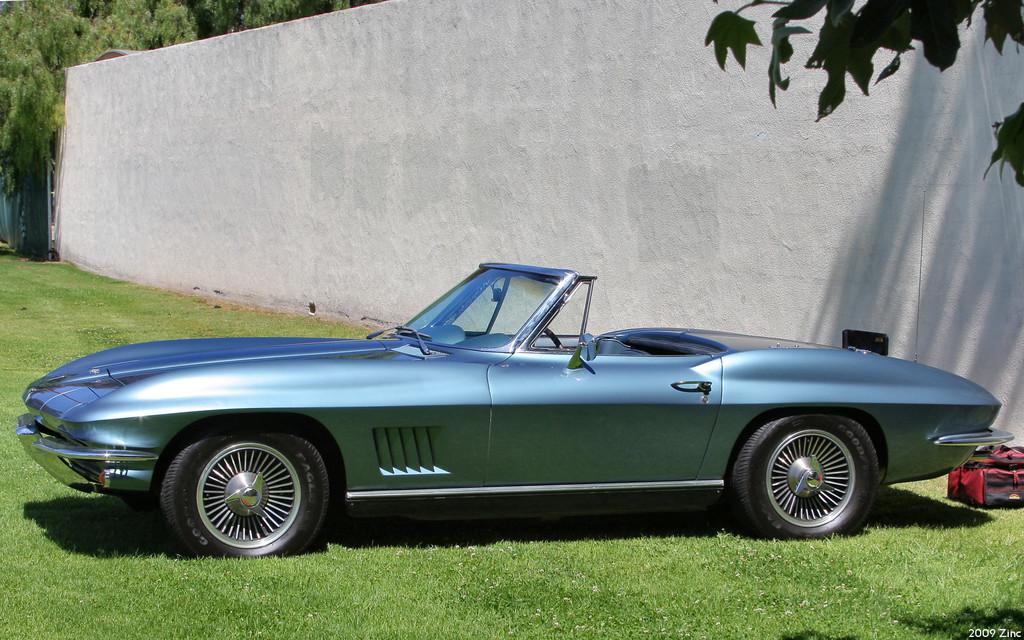What is the color of the wall in the image? The wall in the image is white. What type of vegetation can be seen in the image? There is grass visible in the image. What is the color of the car in the image? The car in the image is blue. What object can be used for carrying items in the image? There is a bag in the image. What can be seen in the background of the image? There are trees in the background of the image. Can you tell me what type of doctor is playing with the bag in the image? There is no doctor or play activity present in the image. What is the range of the trees in the background of the image? The range of the trees cannot be determined from the image, as it only shows their presence in the background. 